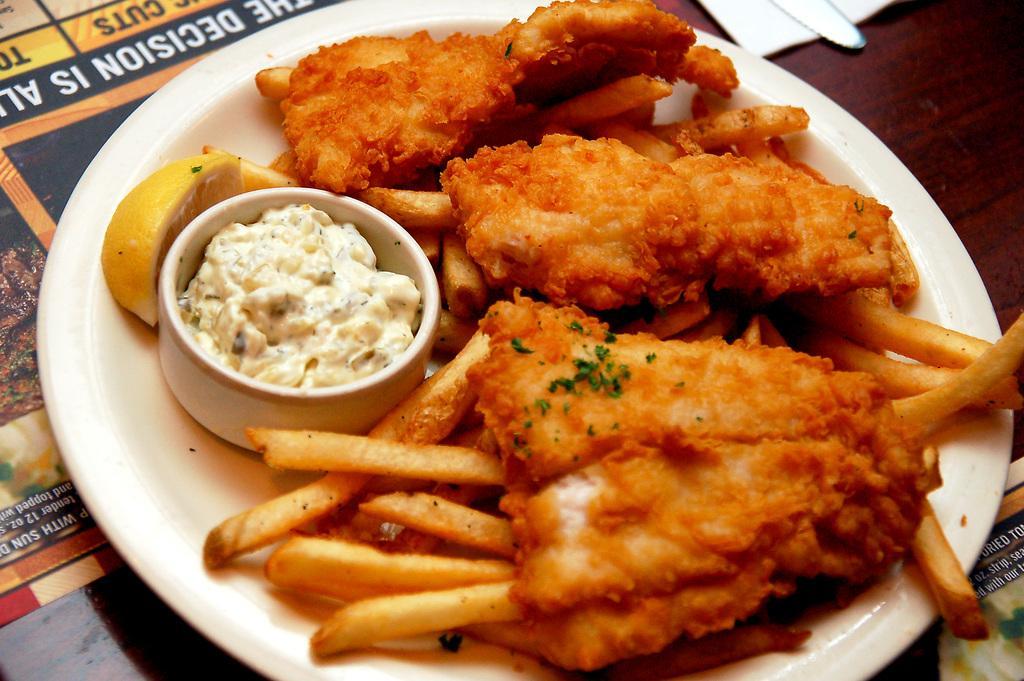Can you describe this image briefly? In this image I can see a brown colored table and on it I can see a paper and a white colored plate. On the plate I can see few french fries, a white colored bowl with sauce in it, a lemon piece and a food item which is brown and cream in color. 